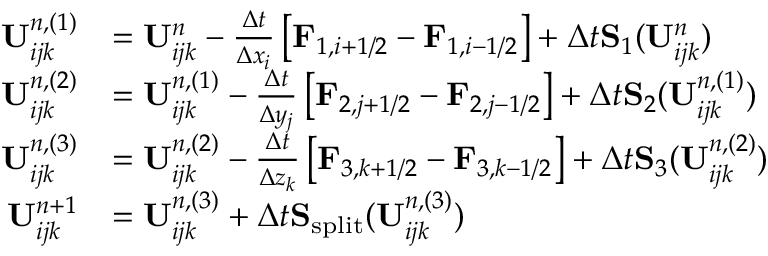<formula> <loc_0><loc_0><loc_500><loc_500>\begin{array} { r l } { U _ { i j k } ^ { n , ( 1 ) } } & { = U _ { i j k } ^ { n } - \frac { \Delta t } { \Delta x _ { i } } \left [ F _ { 1 , i + 1 / 2 } - F _ { 1 , i - 1 / 2 } \right ] + \Delta t S _ { 1 } ( U _ { i j k } ^ { n } ) } \\ { U _ { i j k } ^ { n , ( 2 ) } } & { = U _ { i j k } ^ { n , ( 1 ) } - \frac { \Delta t } { \Delta y _ { j } } \left [ F _ { 2 , j + 1 / 2 } - F _ { 2 , j - 1 / 2 } \right ] + \Delta t S _ { 2 } ( U _ { i j k } ^ { n , ( 1 ) } ) } \\ { U _ { i j k } ^ { n , ( 3 ) } } & { = U _ { i j k } ^ { n , ( 2 ) } - \frac { \Delta t } { \Delta z _ { k } } \left [ F _ { 3 , k + 1 / 2 } - F _ { 3 , k - 1 / 2 } \right ] + \Delta t S _ { 3 } ( U _ { i j k } ^ { n , ( 2 ) } ) } \\ { U _ { i j k } ^ { n + 1 } } & { = U _ { i j k } ^ { n , ( 3 ) } + \Delta t S _ { s p l i t } ( U _ { i j k } ^ { n , ( 3 ) } ) } \end{array}</formula> 